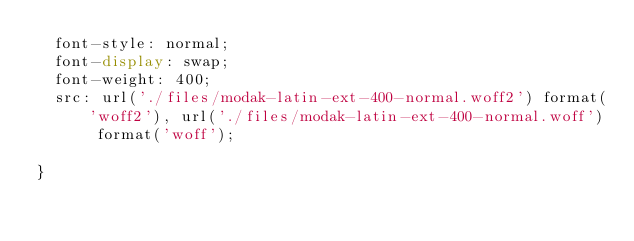<code> <loc_0><loc_0><loc_500><loc_500><_CSS_>  font-style: normal;
  font-display: swap;
  font-weight: 400;
  src: url('./files/modak-latin-ext-400-normal.woff2') format('woff2'), url('./files/modak-latin-ext-400-normal.woff') format('woff');
  
}
</code> 